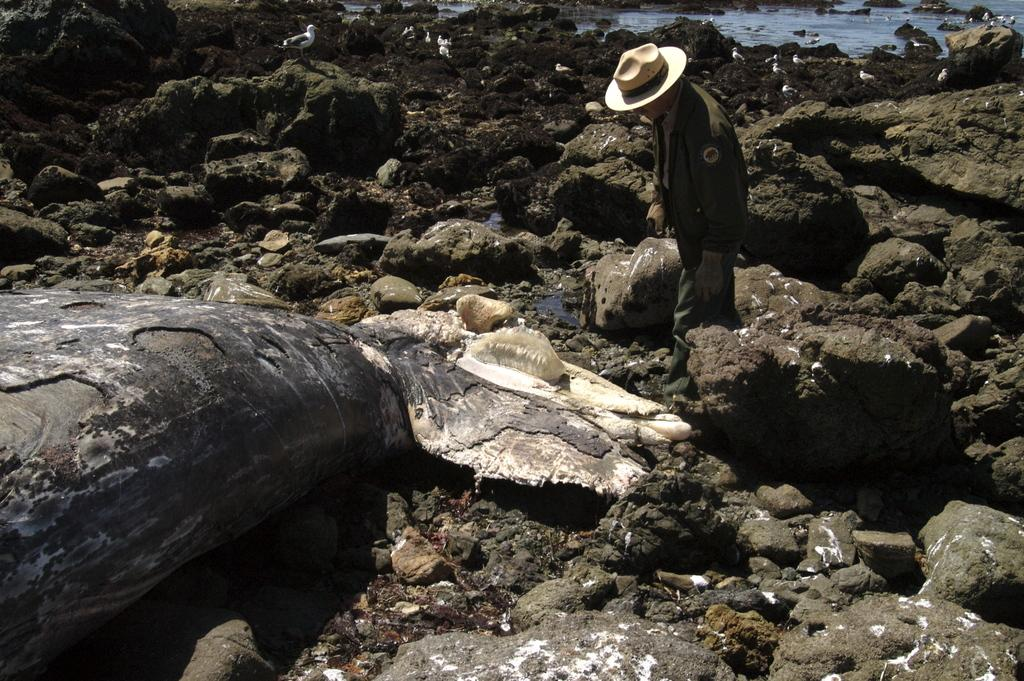Who or what is present in the image? There is a person in the image. What is the person wearing on their head? The person is wearing a cap. What is the person's posture in the image? The person is standing. What type of natural elements can be seen in the image? There are mud stones visible in the image. What type of leaf is the person holding in the image? There is no leaf present in the image. Can you tell me what the person's nose looks like in the image? The image does not provide enough detail to describe the person's nose. 